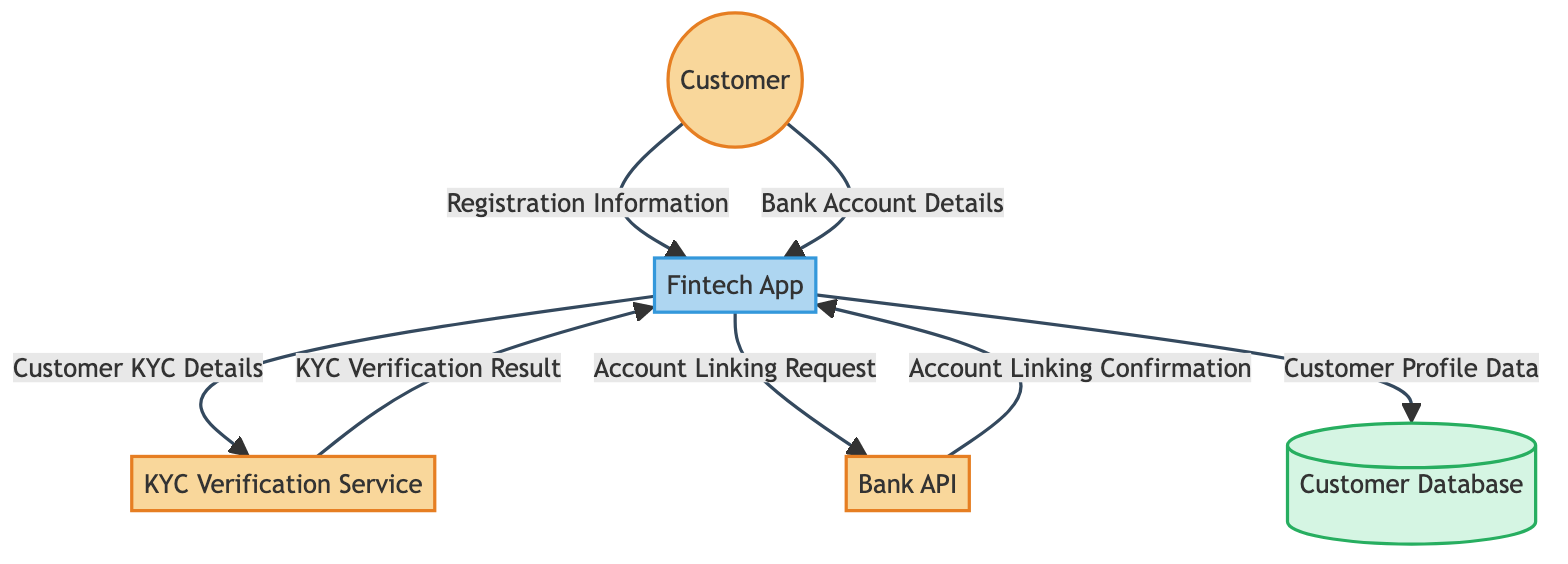What is the first data flow in the diagram? The first data flow originates from the Customer, providing "Registration Information" to the Fintech App. This can be identified by looking at the arrows and reading the labels associated with the first interaction in the flow.
Answer: Registration Information How many external entities are represented in the diagram? The diagram features four external entities: Customer, KYC Verification Service, Bank API, and the Fintech App itself. By counting the labeled nodes marked as external entities, we establish the total.
Answer: Four What data is sent by the Fintech App to the KYC Verification Service? The data that flows from the Fintech App to the KYC Verification Service is described as "Customer KYC Details." This can be found on the arrow indicating the direction of data flow to the KYC Verification Service.
Answer: Customer KYC Details What confirmation is received from the Bank API? The Bank API sends "Account Linking Confirmation" back to the Fintech App. This can be determined by tracing the data flow from the Bank API back to the Fintech App and reading the label on that specific arrow.
Answer: Account Linking Confirmation Which data store does the Fintech App send customer profile data to? The Fintech App sends the "Customer Profile Data" to the Customer Database. This can be verified by following the flow from the Fintech App to the designated data store labeled as Customer Database.
Answer: Customer Database How many data flows are depicted in the diagram? There are six distinct data flows in the diagram, which can be counted by looking at each arrow indicating the movement of data between entities and the data store.
Answer: Six What type of service is the KYC Verification Service? The KYC Verification Service is categorized as an "External System." This can be identified by reading the label associated with the KYC Verification Service entity in the diagram.
Answer: External System What role does the Fintech App play in the diagram? The Fintech App is classified as a "System" in the context of the diagram. This designation is noted in its description, distinguishing its function in processing customer interactions.
Answer: System 